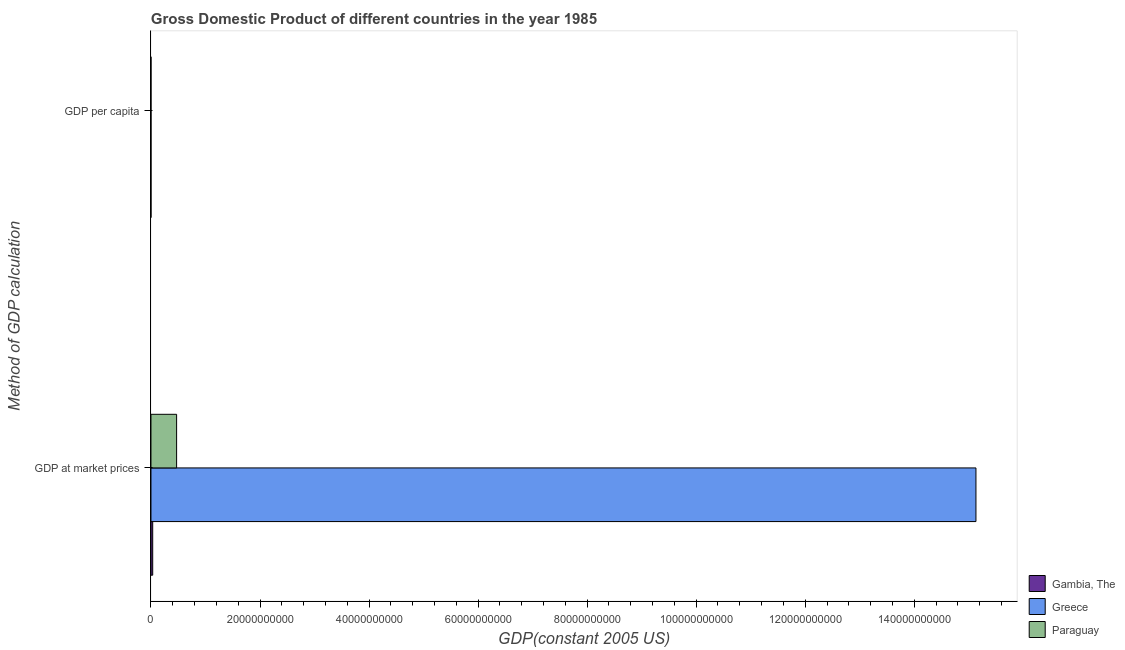How many groups of bars are there?
Make the answer very short. 2. How many bars are there on the 1st tick from the top?
Make the answer very short. 3. How many bars are there on the 1st tick from the bottom?
Offer a terse response. 3. What is the label of the 2nd group of bars from the top?
Your answer should be very brief. GDP at market prices. What is the gdp at market prices in Gambia, The?
Provide a short and direct response. 3.19e+08. Across all countries, what is the maximum gdp per capita?
Offer a very short reply. 1.52e+04. Across all countries, what is the minimum gdp per capita?
Offer a very short reply. 435.2. In which country was the gdp per capita maximum?
Keep it short and to the point. Greece. In which country was the gdp at market prices minimum?
Offer a terse response. Gambia, The. What is the total gdp at market prices in the graph?
Make the answer very short. 1.56e+11. What is the difference between the gdp per capita in Paraguay and that in Gambia, The?
Keep it short and to the point. 845.89. What is the difference between the gdp at market prices in Greece and the gdp per capita in Paraguay?
Offer a terse response. 1.51e+11. What is the average gdp at market prices per country?
Offer a terse response. 5.21e+1. What is the difference between the gdp per capita and gdp at market prices in Paraguay?
Provide a succinct answer. -4.70e+09. What is the ratio of the gdp per capita in Greece to that in Paraguay?
Offer a terse response. 11.89. In how many countries, is the gdp at market prices greater than the average gdp at market prices taken over all countries?
Make the answer very short. 1. What does the 3rd bar from the top in GDP at market prices represents?
Your answer should be compact. Gambia, The. What does the 3rd bar from the bottom in GDP at market prices represents?
Provide a short and direct response. Paraguay. How many countries are there in the graph?
Give a very brief answer. 3. Does the graph contain any zero values?
Your answer should be compact. No. Does the graph contain grids?
Provide a short and direct response. No. Where does the legend appear in the graph?
Your answer should be very brief. Bottom right. How are the legend labels stacked?
Ensure brevity in your answer.  Vertical. What is the title of the graph?
Make the answer very short. Gross Domestic Product of different countries in the year 1985. What is the label or title of the X-axis?
Give a very brief answer. GDP(constant 2005 US). What is the label or title of the Y-axis?
Provide a succinct answer. Method of GDP calculation. What is the GDP(constant 2005 US) in Gambia, The in GDP at market prices?
Make the answer very short. 3.19e+08. What is the GDP(constant 2005 US) of Greece in GDP at market prices?
Provide a succinct answer. 1.51e+11. What is the GDP(constant 2005 US) in Paraguay in GDP at market prices?
Ensure brevity in your answer.  4.70e+09. What is the GDP(constant 2005 US) of Gambia, The in GDP per capita?
Offer a terse response. 435.2. What is the GDP(constant 2005 US) of Greece in GDP per capita?
Your response must be concise. 1.52e+04. What is the GDP(constant 2005 US) of Paraguay in GDP per capita?
Provide a succinct answer. 1281.09. Across all Method of GDP calculation, what is the maximum GDP(constant 2005 US) of Gambia, The?
Make the answer very short. 3.19e+08. Across all Method of GDP calculation, what is the maximum GDP(constant 2005 US) of Greece?
Your answer should be very brief. 1.51e+11. Across all Method of GDP calculation, what is the maximum GDP(constant 2005 US) of Paraguay?
Offer a very short reply. 4.70e+09. Across all Method of GDP calculation, what is the minimum GDP(constant 2005 US) in Gambia, The?
Keep it short and to the point. 435.2. Across all Method of GDP calculation, what is the minimum GDP(constant 2005 US) in Greece?
Keep it short and to the point. 1.52e+04. Across all Method of GDP calculation, what is the minimum GDP(constant 2005 US) of Paraguay?
Make the answer very short. 1281.09. What is the total GDP(constant 2005 US) of Gambia, The in the graph?
Make the answer very short. 3.19e+08. What is the total GDP(constant 2005 US) in Greece in the graph?
Your answer should be very brief. 1.51e+11. What is the total GDP(constant 2005 US) of Paraguay in the graph?
Your response must be concise. 4.70e+09. What is the difference between the GDP(constant 2005 US) of Gambia, The in GDP at market prices and that in GDP per capita?
Make the answer very short. 3.19e+08. What is the difference between the GDP(constant 2005 US) in Greece in GDP at market prices and that in GDP per capita?
Provide a succinct answer. 1.51e+11. What is the difference between the GDP(constant 2005 US) of Paraguay in GDP at market prices and that in GDP per capita?
Keep it short and to the point. 4.70e+09. What is the difference between the GDP(constant 2005 US) of Gambia, The in GDP at market prices and the GDP(constant 2005 US) of Greece in GDP per capita?
Provide a succinct answer. 3.19e+08. What is the difference between the GDP(constant 2005 US) of Gambia, The in GDP at market prices and the GDP(constant 2005 US) of Paraguay in GDP per capita?
Provide a succinct answer. 3.19e+08. What is the difference between the GDP(constant 2005 US) in Greece in GDP at market prices and the GDP(constant 2005 US) in Paraguay in GDP per capita?
Keep it short and to the point. 1.51e+11. What is the average GDP(constant 2005 US) of Gambia, The per Method of GDP calculation?
Your answer should be very brief. 1.59e+08. What is the average GDP(constant 2005 US) of Greece per Method of GDP calculation?
Offer a terse response. 7.57e+1. What is the average GDP(constant 2005 US) in Paraguay per Method of GDP calculation?
Offer a very short reply. 2.35e+09. What is the difference between the GDP(constant 2005 US) in Gambia, The and GDP(constant 2005 US) in Greece in GDP at market prices?
Ensure brevity in your answer.  -1.51e+11. What is the difference between the GDP(constant 2005 US) of Gambia, The and GDP(constant 2005 US) of Paraguay in GDP at market prices?
Ensure brevity in your answer.  -4.39e+09. What is the difference between the GDP(constant 2005 US) of Greece and GDP(constant 2005 US) of Paraguay in GDP at market prices?
Keep it short and to the point. 1.47e+11. What is the difference between the GDP(constant 2005 US) in Gambia, The and GDP(constant 2005 US) in Greece in GDP per capita?
Provide a short and direct response. -1.48e+04. What is the difference between the GDP(constant 2005 US) in Gambia, The and GDP(constant 2005 US) in Paraguay in GDP per capita?
Provide a succinct answer. -845.89. What is the difference between the GDP(constant 2005 US) in Greece and GDP(constant 2005 US) in Paraguay in GDP per capita?
Provide a short and direct response. 1.40e+04. What is the ratio of the GDP(constant 2005 US) in Gambia, The in GDP at market prices to that in GDP per capita?
Keep it short and to the point. 7.32e+05. What is the ratio of the GDP(constant 2005 US) in Greece in GDP at market prices to that in GDP per capita?
Provide a short and direct response. 9.93e+06. What is the ratio of the GDP(constant 2005 US) in Paraguay in GDP at market prices to that in GDP per capita?
Keep it short and to the point. 3.67e+06. What is the difference between the highest and the second highest GDP(constant 2005 US) of Gambia, The?
Offer a terse response. 3.19e+08. What is the difference between the highest and the second highest GDP(constant 2005 US) in Greece?
Keep it short and to the point. 1.51e+11. What is the difference between the highest and the second highest GDP(constant 2005 US) in Paraguay?
Ensure brevity in your answer.  4.70e+09. What is the difference between the highest and the lowest GDP(constant 2005 US) of Gambia, The?
Keep it short and to the point. 3.19e+08. What is the difference between the highest and the lowest GDP(constant 2005 US) in Greece?
Make the answer very short. 1.51e+11. What is the difference between the highest and the lowest GDP(constant 2005 US) of Paraguay?
Keep it short and to the point. 4.70e+09. 